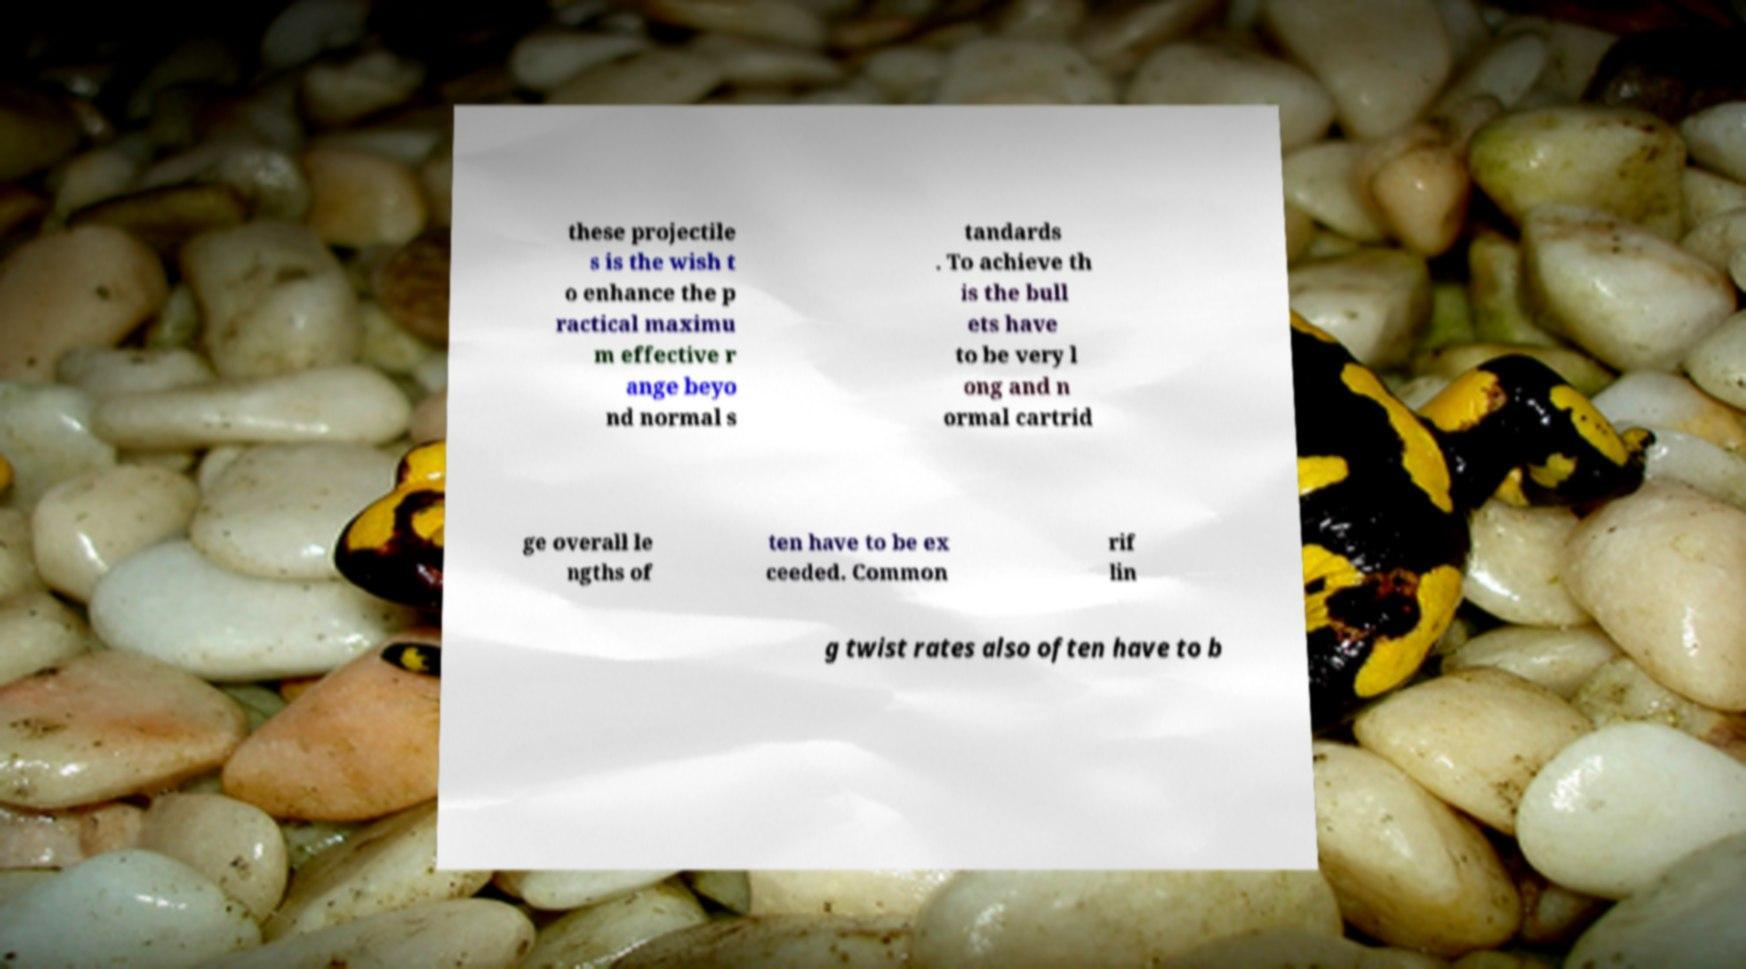Can you accurately transcribe the text from the provided image for me? these projectile s is the wish t o enhance the p ractical maximu m effective r ange beyo nd normal s tandards . To achieve th is the bull ets have to be very l ong and n ormal cartrid ge overall le ngths of ten have to be ex ceeded. Common rif lin g twist rates also often have to b 